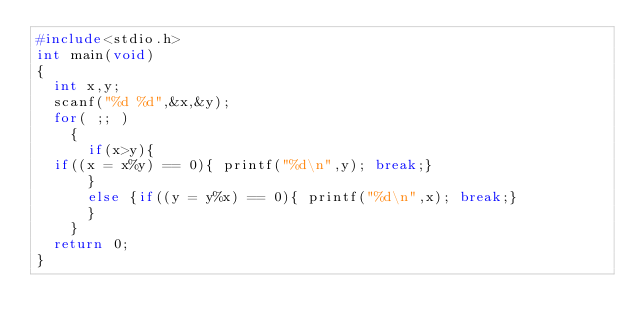<code> <loc_0><loc_0><loc_500><loc_500><_C_>#include<stdio.h>
int main(void)
{
  int x,y;
  scanf("%d %d",&x,&y);
  for( ;; )
    {
      if(x>y){
	if((x = x%y) == 0){ printf("%d\n",y); break;}
      }
      else {if((y = y%x) == 0){ printf("%d\n",x); break;}
      }
    }
  return 0;
}</code> 